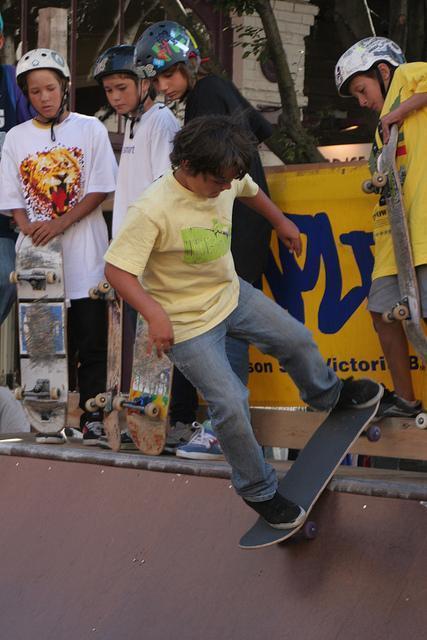How many kids are wearing helmets?
Give a very brief answer. 4. How many skateboards are visible?
Give a very brief answer. 5. How many people can you see?
Give a very brief answer. 5. How many donuts are read with black face?
Give a very brief answer. 0. 